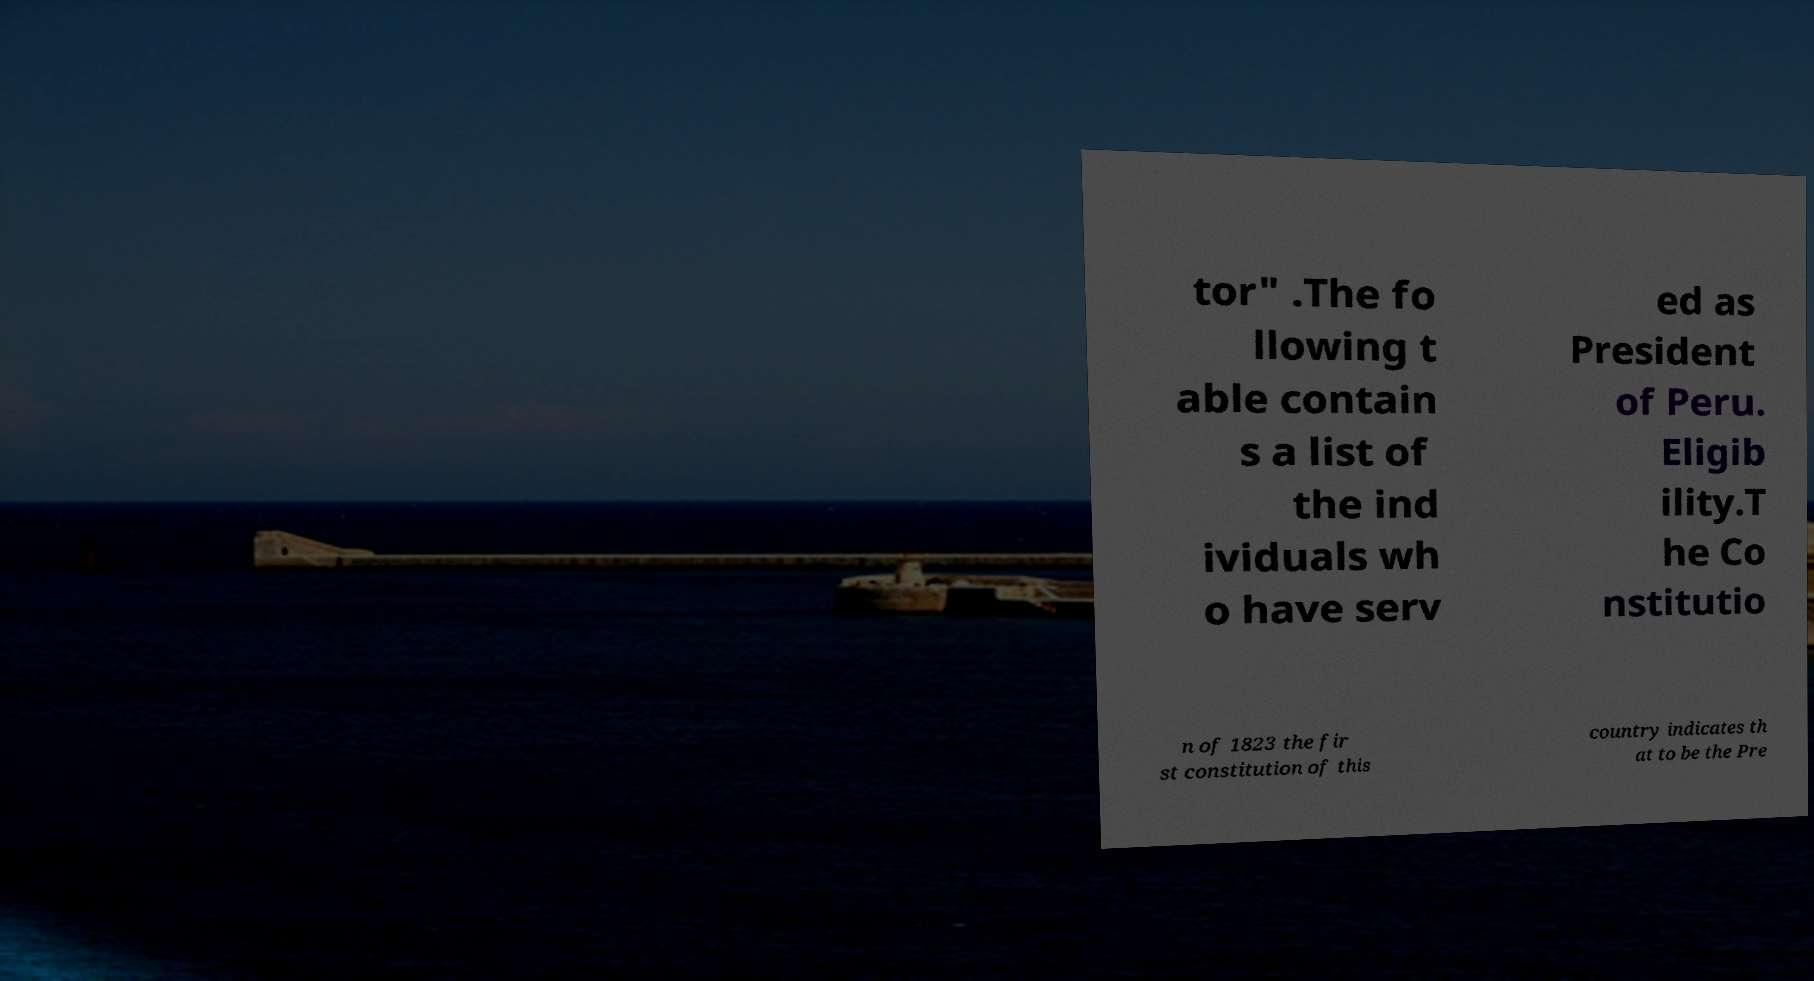I need the written content from this picture converted into text. Can you do that? tor" .The fo llowing t able contain s a list of the ind ividuals wh o have serv ed as President of Peru. Eligib ility.T he Co nstitutio n of 1823 the fir st constitution of this country indicates th at to be the Pre 